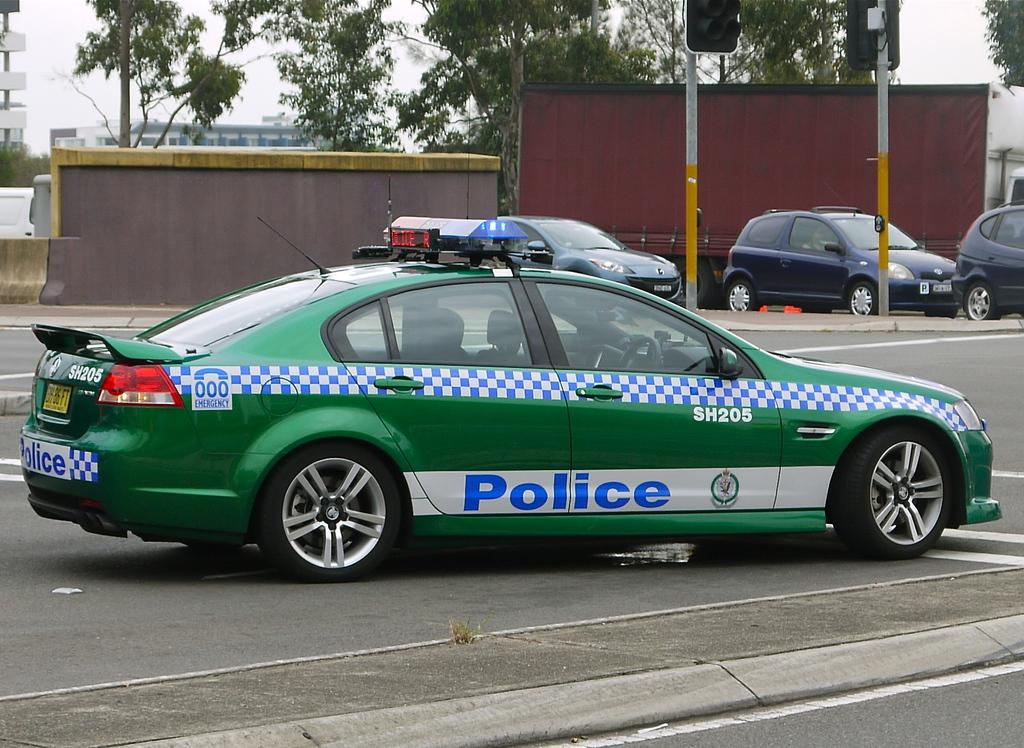What is the identifying number on this police vehicle?
Provide a succinct answer. Sh205. 